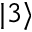Convert formula to latex. <formula><loc_0><loc_0><loc_500><loc_500>| 3 \rangle</formula> 